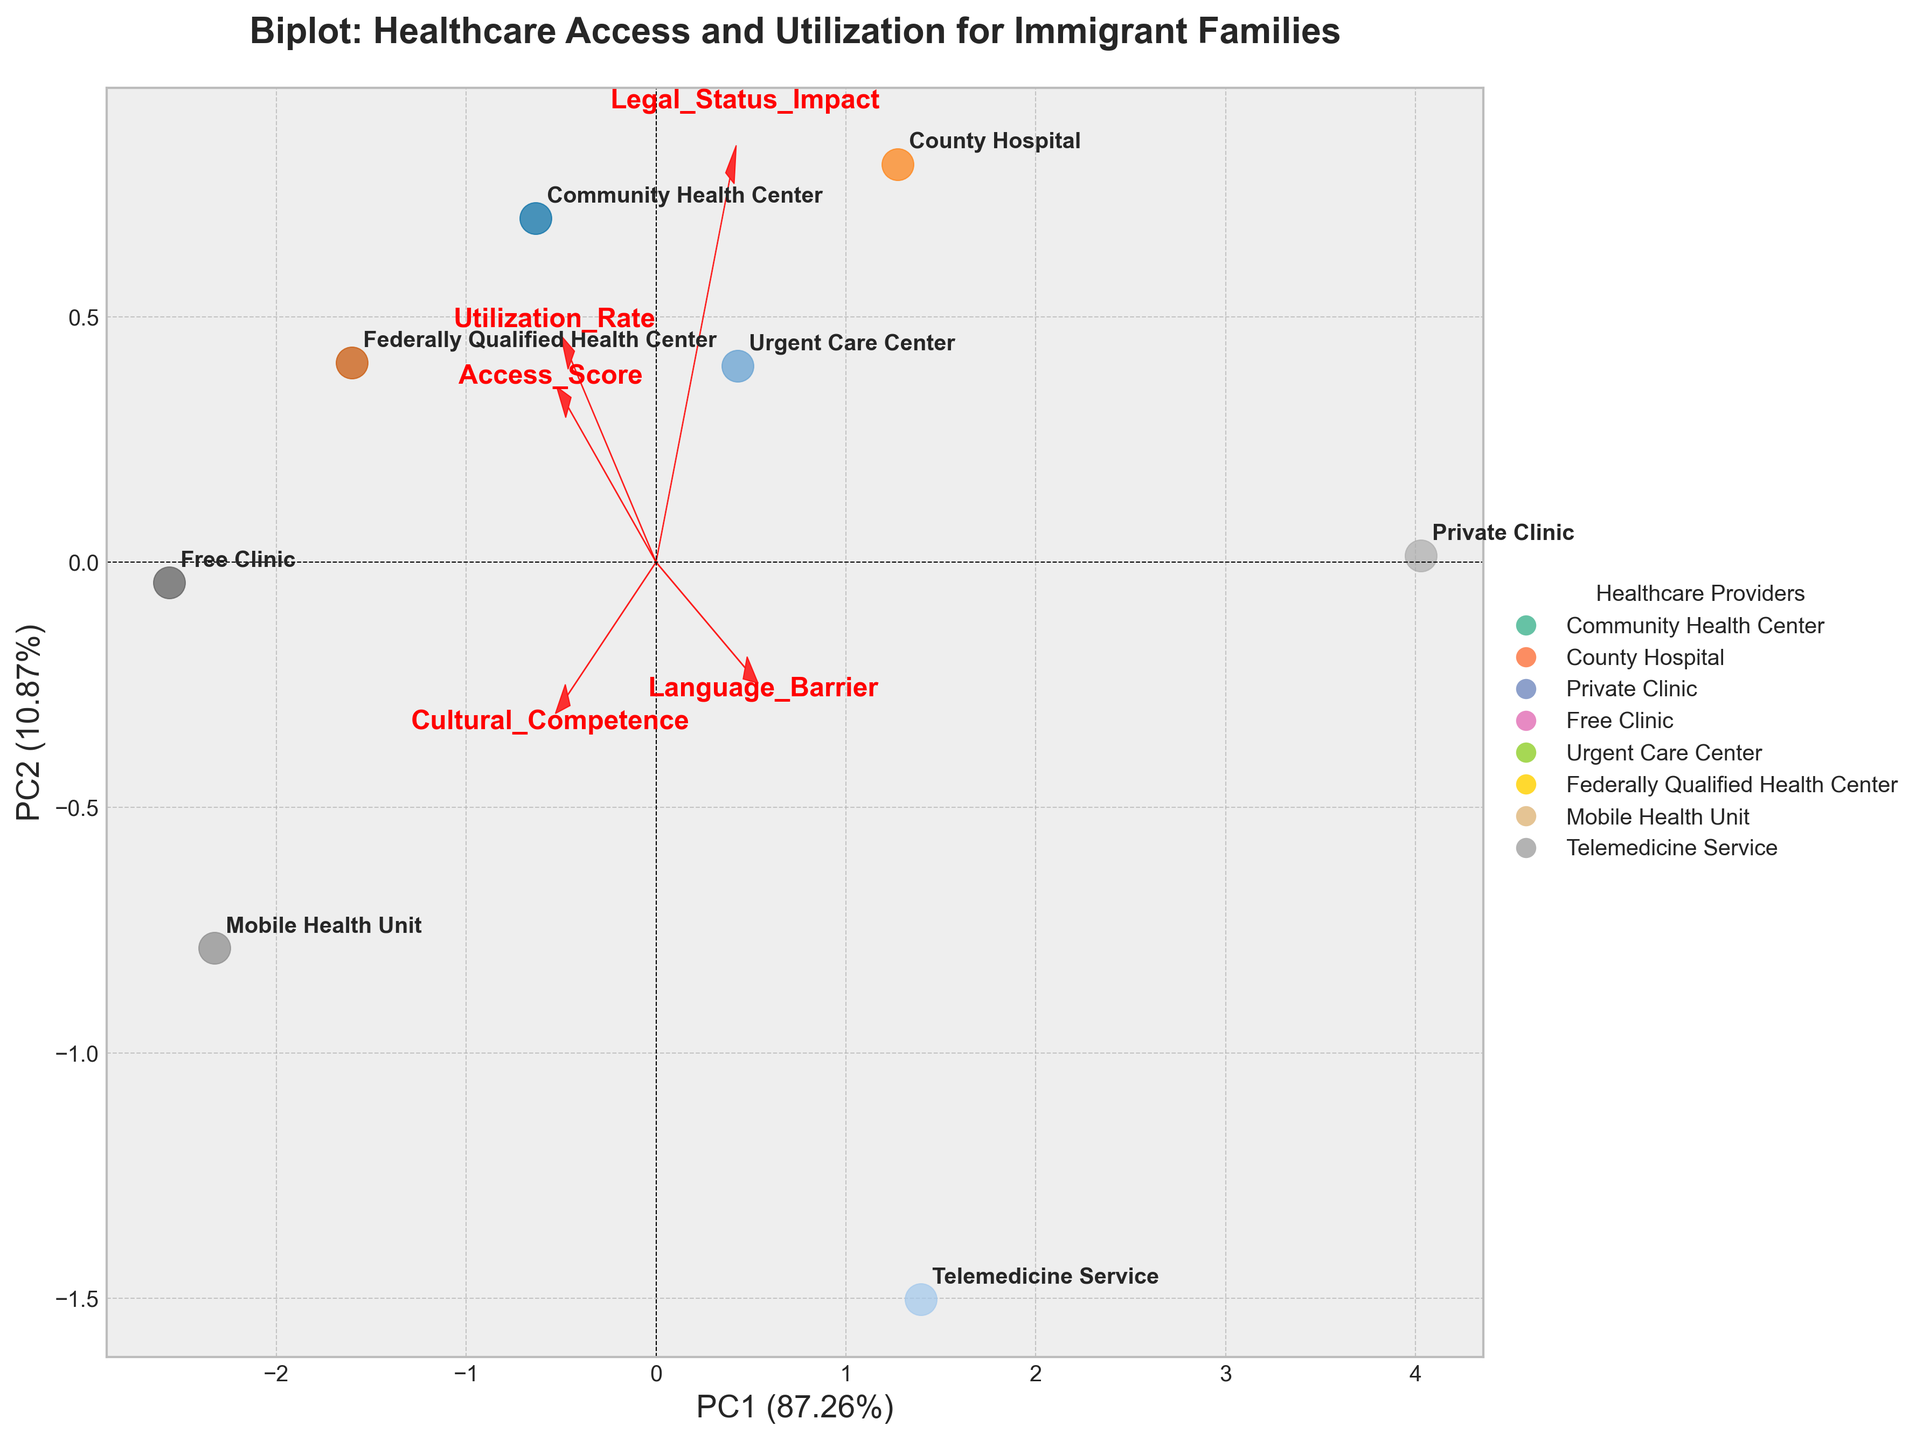How many healthcare providers are represented in the biplot? The biplot displays markers for each healthcare provider. By counting these markers, we find there are 8 healthcare providers.
Answer: 8 What are the axes labeled in the biplot? The x-axis is labeled 'PC1' indicating the first principal component, and the y-axis is labeled 'PC2' indicating the second principal component.
Answer: PC1 and PC2 Which healthcare provider has the highest utilization rate? By looking for the provider plotted closest to the 'Utilization Rate' loading vector (direction and length) on the biplot, the 'Free Clinic' is situated near the upper part of the plot, indicating the highest utilization rate.
Answer: Free Clinic Among the healthcare providers, which has the most significant impact of language barriers? 'Language Barrier' loading is represented by an arrow pointing in a specific direction. 'Private Clinic,' which is plotted near this loading vector, indicates a high impact of language barriers.
Answer: Private Clinic Do community health centers or county hospitals have higher access scores? Locate the 'Community Health Center' and 'County Hospital' points and determine their proximity to the 'Access_Score' loading arrow. The 'Community Health Center' is closer to the direction of the 'Access_Score' arrow.
Answer: Community Health Center Which healthcare provider shows the highest cultural competence? The 'Cultural_Competence' loading is represented by an arrow, and the 'Mobile Health Unit' is plotted closest to its direction, indicating the highest cultural competence.
Answer: Mobile Health Unit Which principal component (PC) explains more variance in the data? The biplot typically states the explained variance for both PC1 and PC2 on the axes. The x-axis (PC1) has a higher variance percentage than the y-axis (PC2).
Answer: PC1 How do telemedicine services' data points relate to legal status impact? The 'Telemedicine Service' point should be examined in relation to the 'Legal_Status_Impact' vector. It is positioned moderately near, indicating a medium level of impact.
Answer: Medium Which healthcare provider shows both high access scores and low language barriers? Identify the point nearest to the 'Access_Score' arrow's direction while being far from the 'Language_Barrier' direction. 'Federally Qualified Health Center' is the best match fitting this criterion.
Answer: Federally Qualified Health Center 